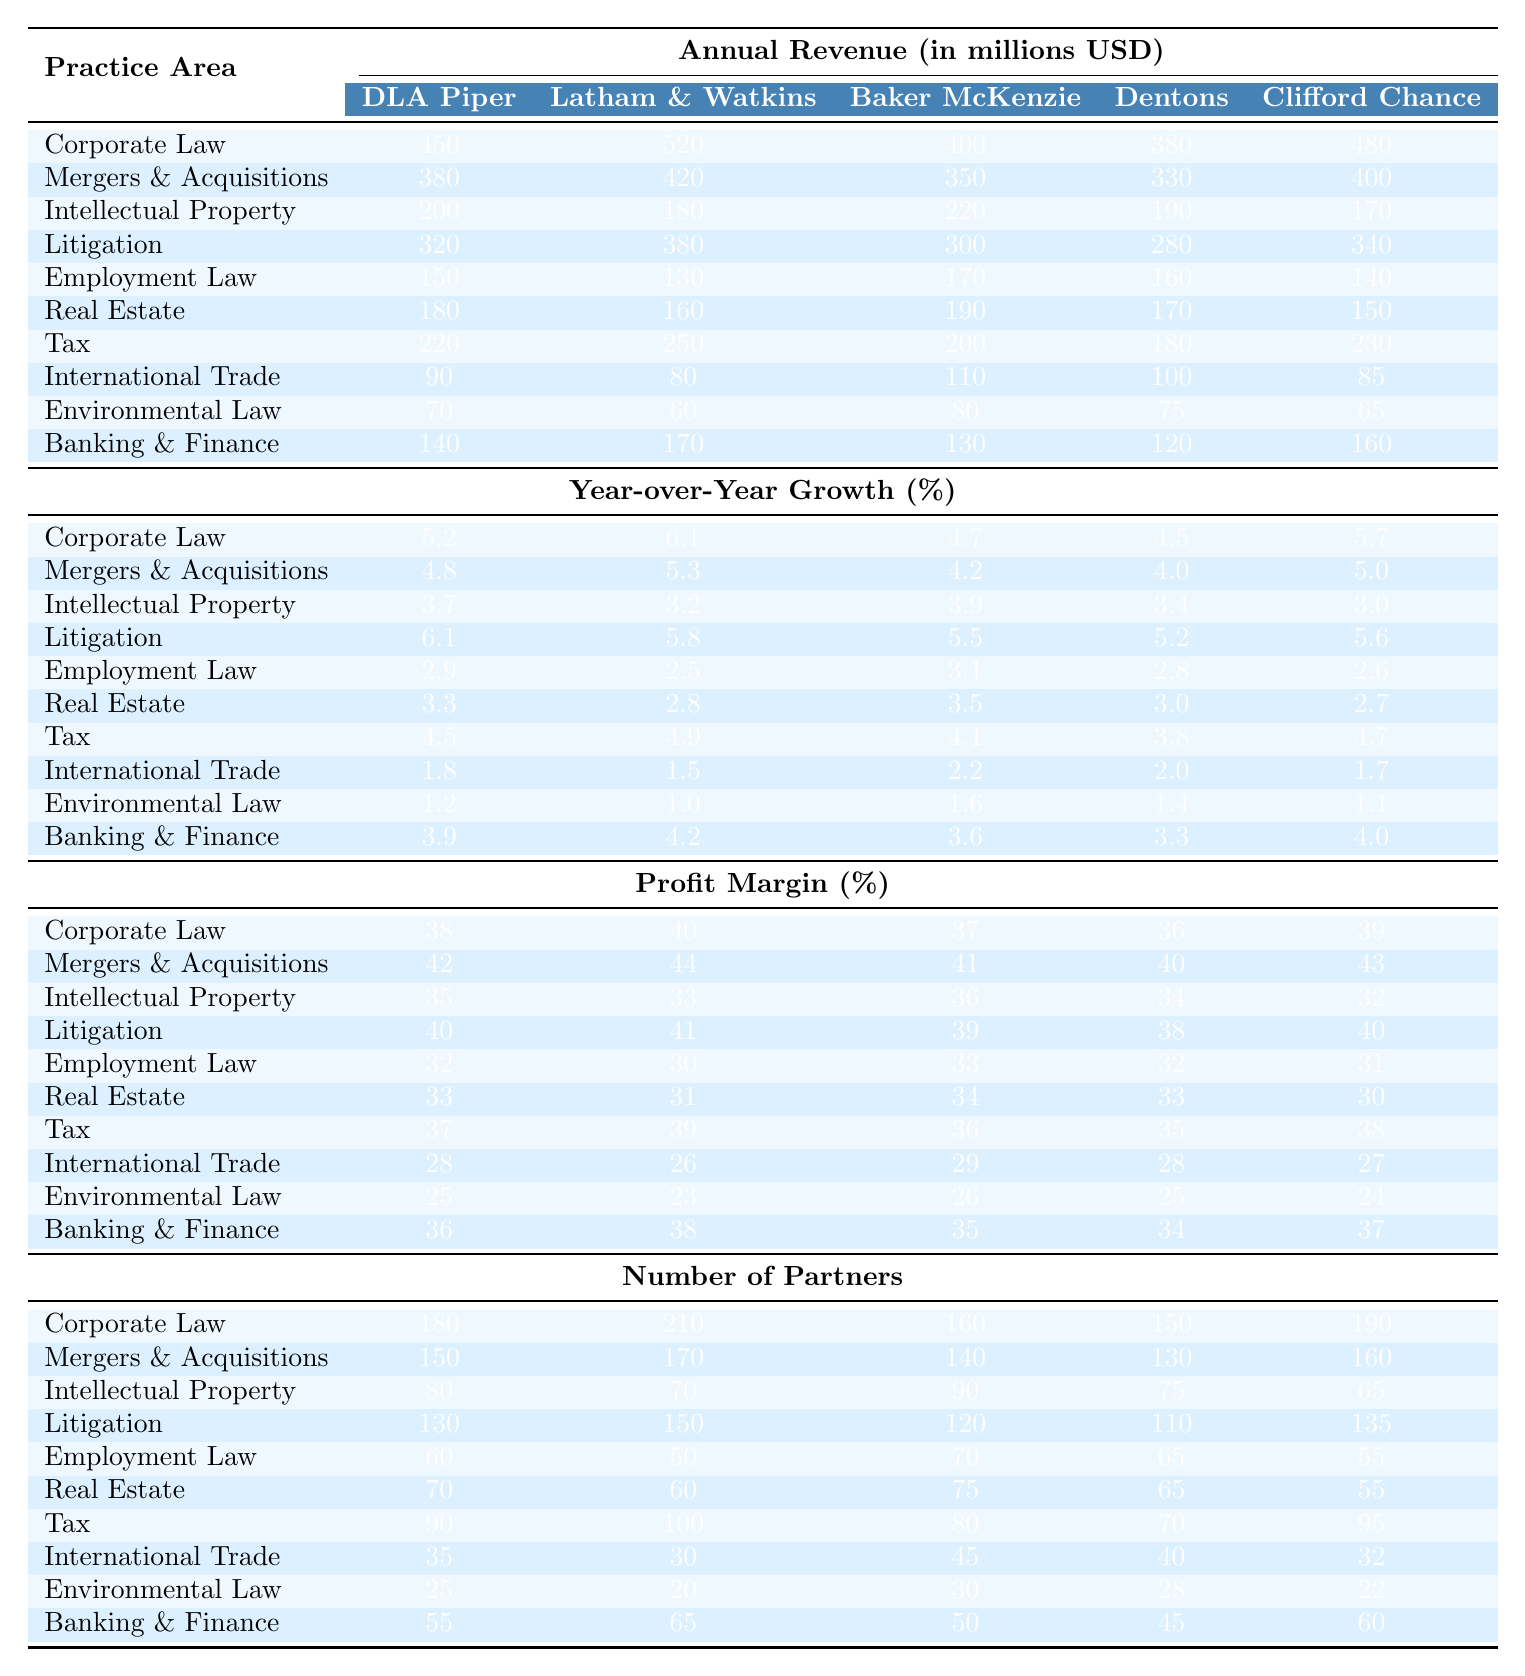What is the annual revenue for Corporate Law at Baker McKenzie? According to the table, the annual revenue for Corporate Law at Baker McKenzie is listed as 400 million USD.
Answer: 400 million USD What was the Year-over-Year Growth for Employment Law at Dentons? The Year-over-Year Growth for Employment Law at Dentons is 2.8%.
Answer: 2.8% Which law firm has the highest profit margin in Mergers & Acquisitions? By comparing the profit margins listed for Mergers & Acquisitions, Latham & Watkins has the highest profit margin at 44%.
Answer: Latham & Watkins What is the average annual revenue for Environmental Law across all firms? The annual revenues for Environmental Law are 70, 60, 80, 75, and 65 million USD. Their sum is 350 million USD, and dividing by 5 gives an average of 70 million USD.
Answer: 70 million USD Which law firm has the largest number of partners in Real Estate practice? Looking at the Real Estate row, Latham & Watkins has 60 partners, which is more than the others (55 for Clifford Chance, 65 for Dentons, 70 for Baker McKenzie, and 50 for DLA Piper).
Answer: Latham & Watkins Is the profit margin for Corporate Law at DLA Piper higher than that at Dentons? The profit margin for Corporate Law at DLA Piper is 38%, while it is 36% at Dentons. Therefore, yes, DLA Piper's margin is higher.
Answer: Yes What is the total annual revenue for all firms in Litigation? The annual revenue for Litigation is summed as follows: 320 (DLA Piper) + 380 (Latham & Watkins) + 300 (Baker McKenzie) + 280 (Dentons) + 340 (Clifford Chance) = 1,600 million USD.
Answer: 1,600 million USD How does the Year-over-Year Growth of Tax compare between DLA Piper and Baker McKenzie? DLA Piper shows a growth of 4.5% and Baker McKenzie shows 4.1%. Hence, DLA Piper has a higher growth rate compared to Baker McKenzie.
Answer: DLA Piper has a higher growth rate What is the difference in the number of partners between Latham & Watkins and Clifford Chance in the Corporate Law area? Latham & Watkins has 210 partners and Clifford Chance has 190 partners in Corporate Law. The difference is 210 - 190 = 20 partners.
Answer: 20 partners Which firm has the least revenue in International Trade? In the International Trade category, Latham & Watkins shows the least revenue at 80 million USD compared to others (90 for DLA Piper, 110 for Baker McKenzie, 100 for Dentons, and 85 for Clifford Chance).
Answer: Latham & Watkins 